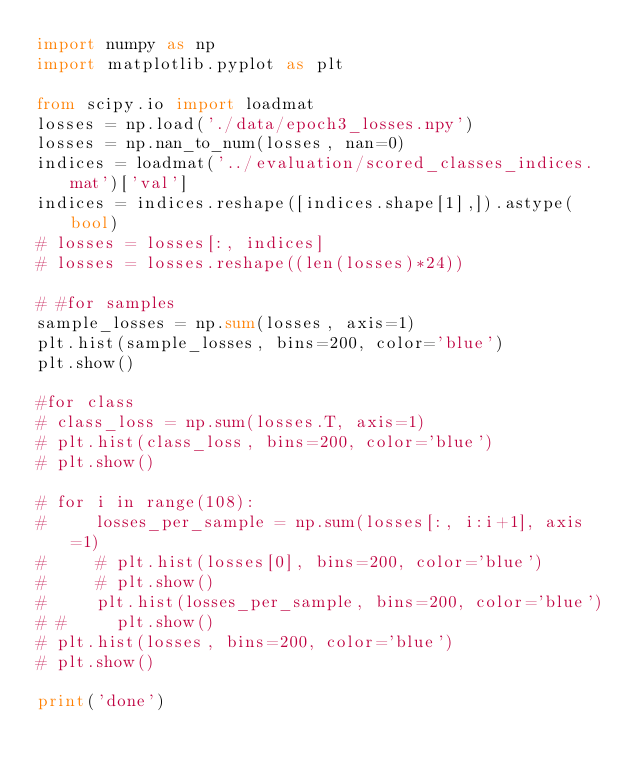<code> <loc_0><loc_0><loc_500><loc_500><_Python_>import numpy as np
import matplotlib.pyplot as plt

from scipy.io import loadmat
losses = np.load('./data/epoch3_losses.npy')
losses = np.nan_to_num(losses, nan=0)
indices = loadmat('../evaluation/scored_classes_indices.mat')['val']
indices = indices.reshape([indices.shape[1],]).astype(bool)
# losses = losses[:, indices]
# losses = losses.reshape((len(losses)*24))

# #for samples
sample_losses = np.sum(losses, axis=1)
plt.hist(sample_losses, bins=200, color='blue')
plt.show()

#for class
# class_loss = np.sum(losses.T, axis=1)
# plt.hist(class_loss, bins=200, color='blue')
# plt.show()

# for i in range(108):
#     losses_per_sample = np.sum(losses[:, i:i+1], axis=1)
#     # plt.hist(losses[0], bins=200, color='blue')
#     # plt.show()
#     plt.hist(losses_per_sample, bins=200, color='blue')
# #     plt.show()
# plt.hist(losses, bins=200, color='blue')
# plt.show()

print('done')</code> 